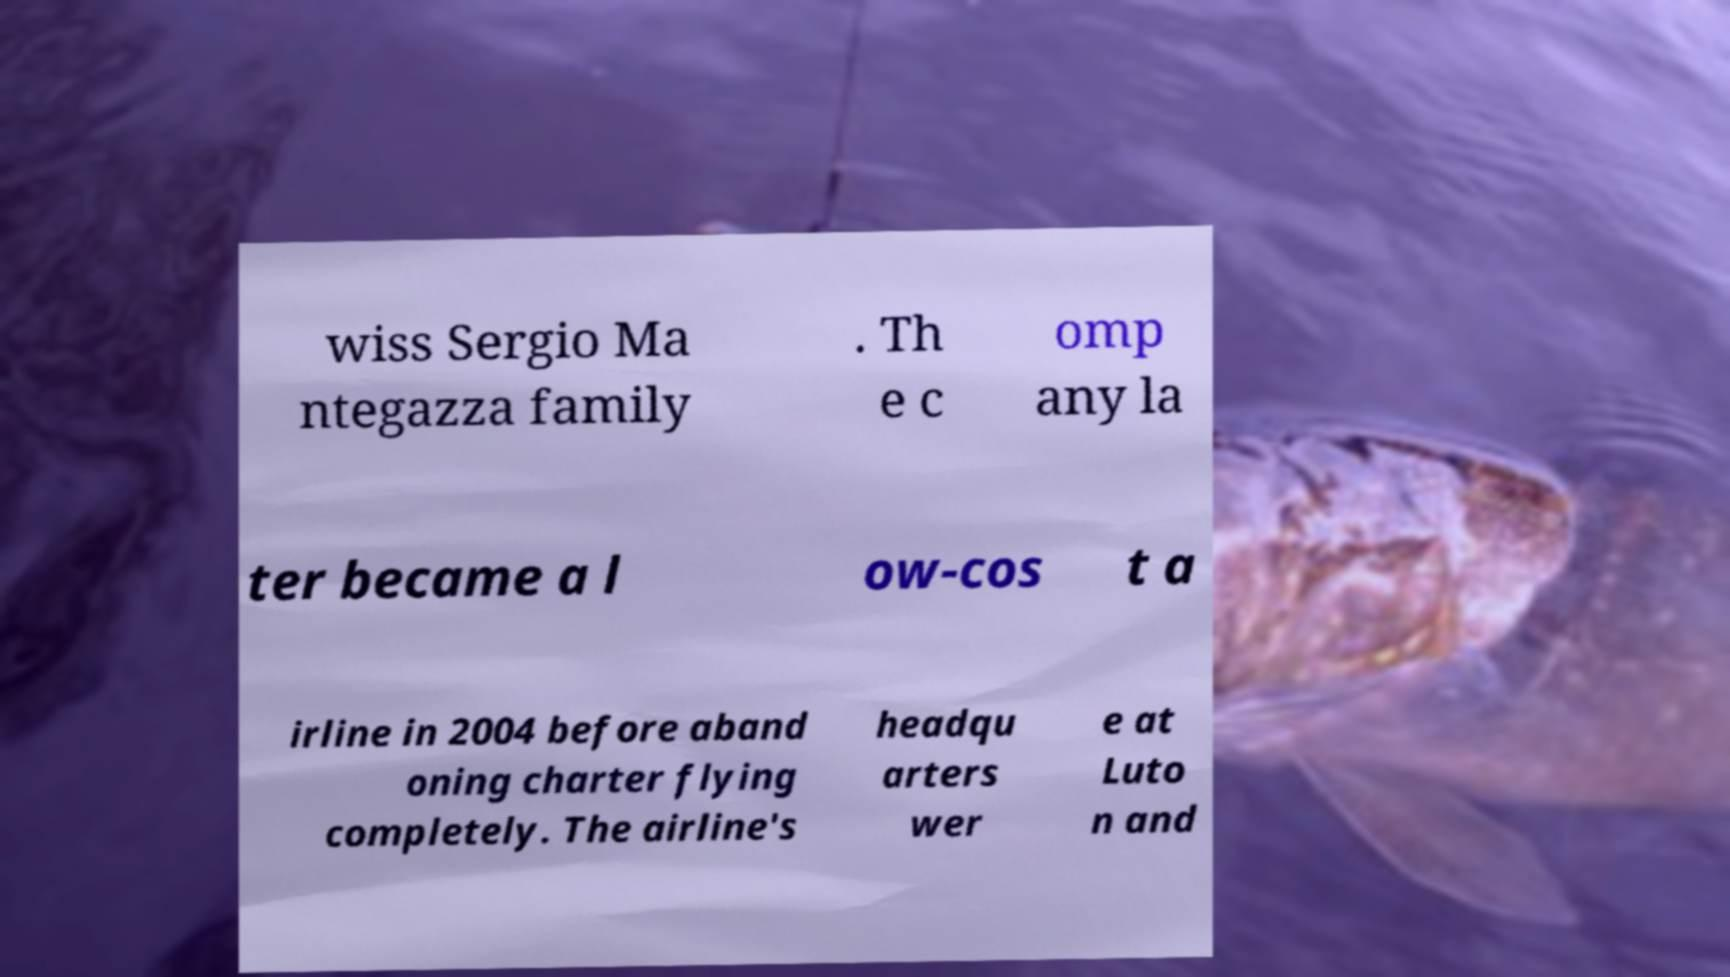Can you read and provide the text displayed in the image?This photo seems to have some interesting text. Can you extract and type it out for me? wiss Sergio Ma ntegazza family . Th e c omp any la ter became a l ow-cos t a irline in 2004 before aband oning charter flying completely. The airline's headqu arters wer e at Luto n and 